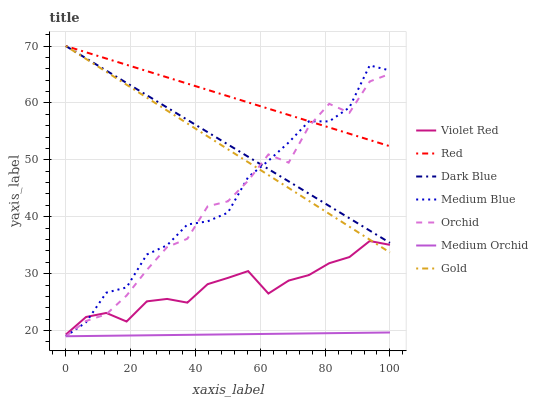Does Medium Orchid have the minimum area under the curve?
Answer yes or no. Yes. Does Red have the maximum area under the curve?
Answer yes or no. Yes. Does Gold have the minimum area under the curve?
Answer yes or no. No. Does Gold have the maximum area under the curve?
Answer yes or no. No. Is Medium Orchid the smoothest?
Answer yes or no. Yes. Is Orchid the roughest?
Answer yes or no. Yes. Is Gold the smoothest?
Answer yes or no. No. Is Gold the roughest?
Answer yes or no. No. Does Gold have the lowest value?
Answer yes or no. No. Does Red have the highest value?
Answer yes or no. Yes. Does Medium Orchid have the highest value?
Answer yes or no. No. Is Violet Red less than Red?
Answer yes or no. Yes. Is Dark Blue greater than Violet Red?
Answer yes or no. Yes. Does Medium Blue intersect Gold?
Answer yes or no. Yes. Is Medium Blue less than Gold?
Answer yes or no. No. Is Medium Blue greater than Gold?
Answer yes or no. No. Does Violet Red intersect Red?
Answer yes or no. No. 